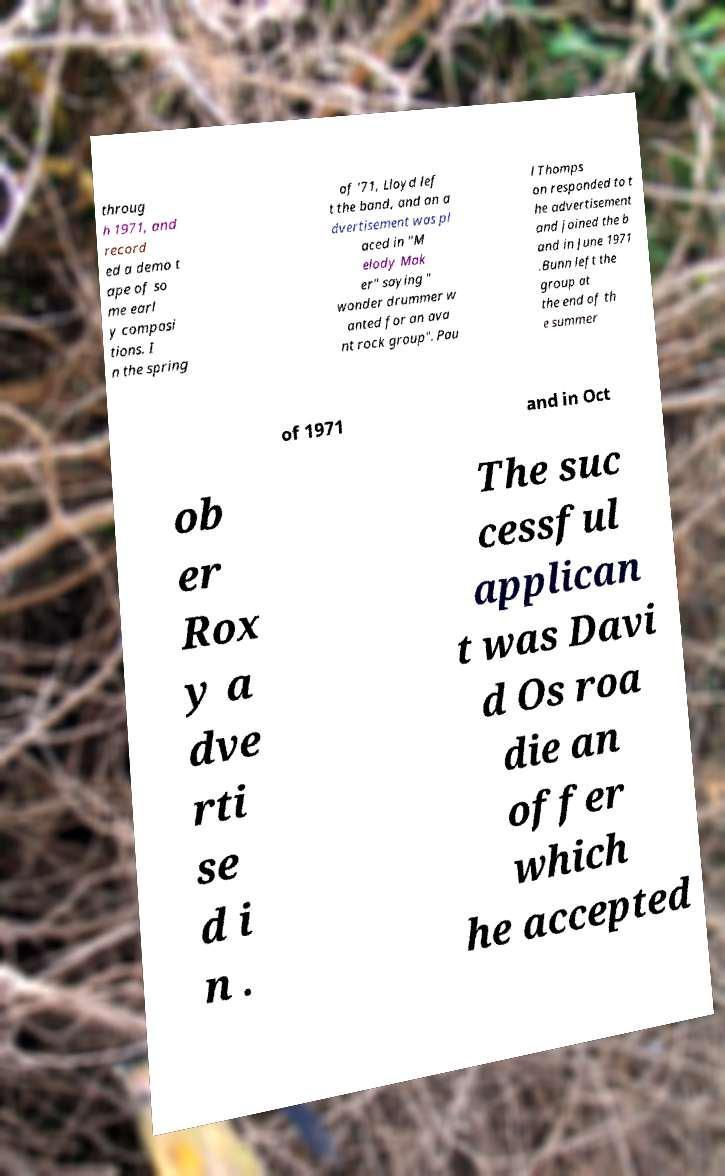I need the written content from this picture converted into text. Can you do that? throug h 1971, and record ed a demo t ape of so me earl y composi tions. I n the spring of '71, Lloyd lef t the band, and an a dvertisement was pl aced in "M elody Mak er" saying " wonder drummer w anted for an ava nt rock group". Pau l Thomps on responded to t he advertisement and joined the b and in June 1971 .Bunn left the group at the end of th e summer of 1971 and in Oct ob er Rox y a dve rti se d i n . The suc cessful applican t was Davi d Os roa die an offer which he accepted 